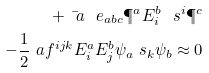<formula> <loc_0><loc_0><loc_500><loc_500>+ \bar { \ a } \ e _ { a b c } \P ^ { a } E ^ { b } _ { i } \ s ^ { i } \P ^ { c } \\ - \frac { 1 } { 2 } \ a f ^ { i j k } E ^ { a } _ { i } E ^ { b } _ { j } \psi _ { a } \ s _ { k } \psi _ { b } \approx 0</formula> 